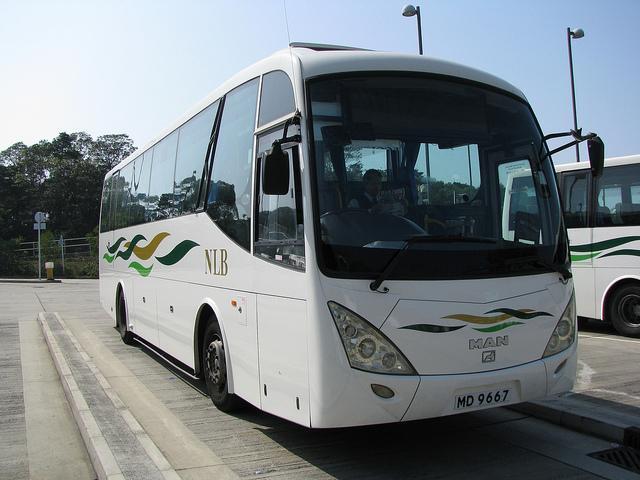How many buses are in this picture?
Give a very brief answer. 2. How many buses are there?
Give a very brief answer. 2. 